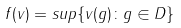Convert formula to latex. <formula><loc_0><loc_0><loc_500><loc_500>f ( v ) = s u p \{ v ( g ) \colon g \in D \}</formula> 